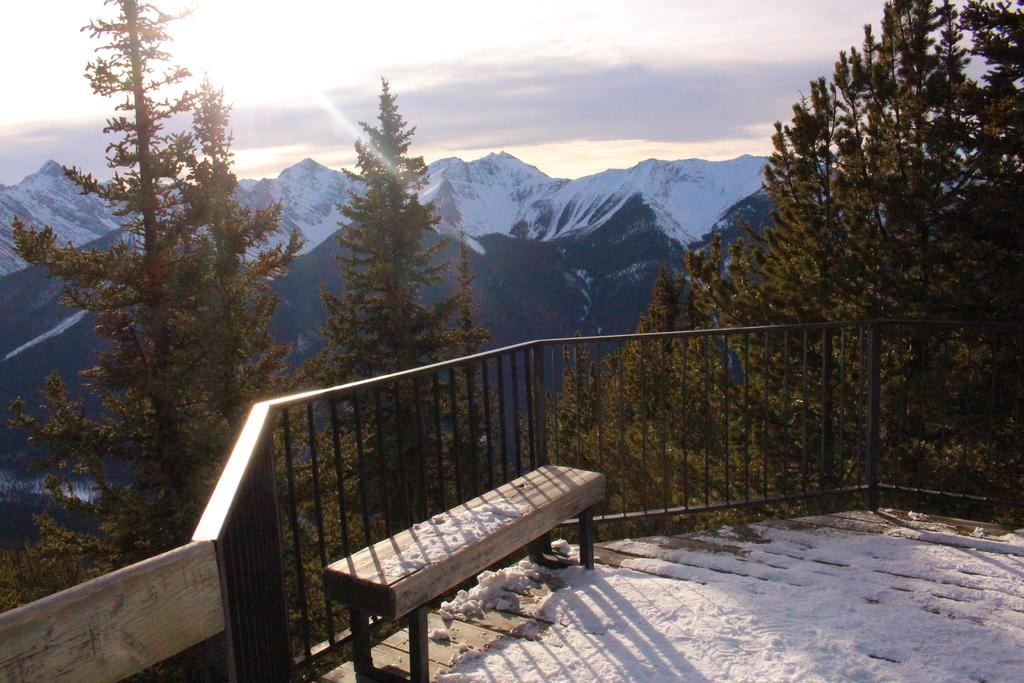What type of seating is visible in the image? There is a bench in the image. What is the purpose of the structure that surrounds the area? There is fencing in the image, which is likely used to enclose or separate the area. What is covering the ground in the image? There is snow on the floor in the image. What can be seen in the distance in the image? There are trees and mountains in the background of the image. What is the condition of the sky in the image? The sky is clear in the background of the image. Where are the clocks located in the image? There are no clocks present in the image. What type of downtown area can be seen in the image? There is no downtown area depicted in the image; it features a bench, fencing, snow, trees, mountains, and a clear sky. 